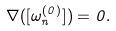<formula> <loc_0><loc_0><loc_500><loc_500>\nabla ( [ \omega _ { n } ^ { ( 0 ) } ] ) = 0 .</formula> 